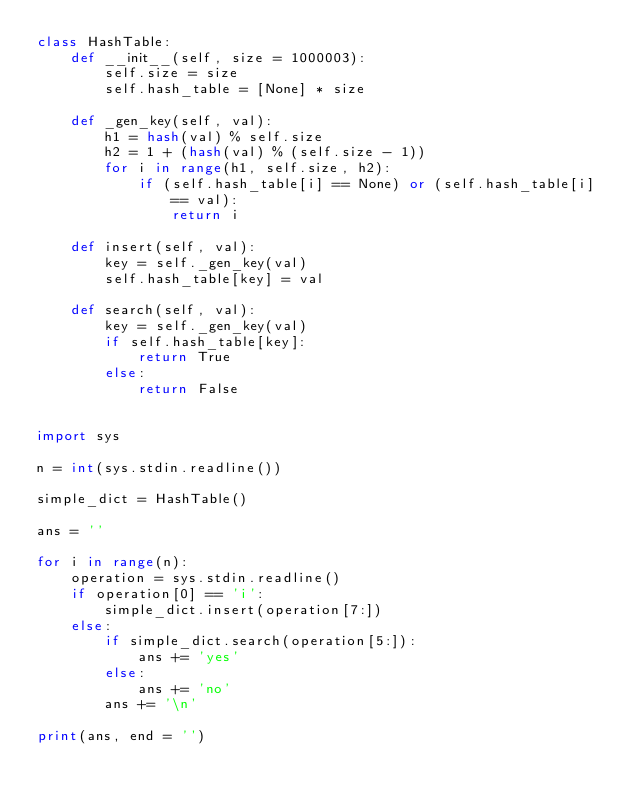<code> <loc_0><loc_0><loc_500><loc_500><_Python_>class HashTable:
    def __init__(self, size = 1000003):
        self.size = size
        self.hash_table = [None] * size

    def _gen_key(self, val):
        h1 = hash(val) % self.size
        h2 = 1 + (hash(val) % (self.size - 1))
        for i in range(h1, self.size, h2):
            if (self.hash_table[i] == None) or (self.hash_table[i] == val):
                return i

    def insert(self, val):
        key = self._gen_key(val)
        self.hash_table[key] = val

    def search(self, val):
        key = self._gen_key(val)
        if self.hash_table[key]:
            return True
        else:
            return False


import sys

n = int(sys.stdin.readline())

simple_dict = HashTable()

ans = ''

for i in range(n):
    operation = sys.stdin.readline()
    if operation[0] == 'i':
        simple_dict.insert(operation[7:])
    else:
        if simple_dict.search(operation[5:]):
            ans += 'yes'
        else:
            ans += 'no'
        ans += '\n'

print(ans, end = '')</code> 